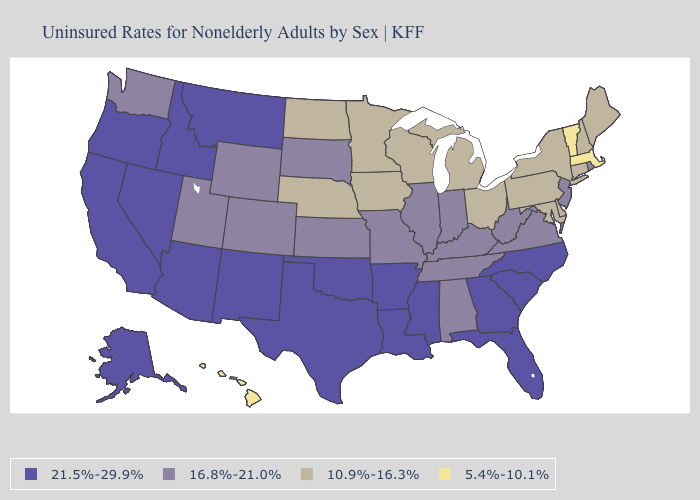What is the value of Nebraska?
Concise answer only. 10.9%-16.3%. Name the states that have a value in the range 10.9%-16.3%?
Quick response, please. Connecticut, Delaware, Iowa, Maine, Maryland, Michigan, Minnesota, Nebraska, New Hampshire, New York, North Dakota, Ohio, Pennsylvania, Wisconsin. Does the map have missing data?
Be succinct. No. Does Utah have a lower value than Georgia?
Quick response, please. Yes. Name the states that have a value in the range 16.8%-21.0%?
Be succinct. Alabama, Colorado, Illinois, Indiana, Kansas, Kentucky, Missouri, New Jersey, Rhode Island, South Dakota, Tennessee, Utah, Virginia, Washington, West Virginia, Wyoming. Name the states that have a value in the range 10.9%-16.3%?
Write a very short answer. Connecticut, Delaware, Iowa, Maine, Maryland, Michigan, Minnesota, Nebraska, New Hampshire, New York, North Dakota, Ohio, Pennsylvania, Wisconsin. What is the highest value in the MidWest ?
Short answer required. 16.8%-21.0%. Does Arkansas have the highest value in the USA?
Keep it brief. Yes. Does Alabama have the lowest value in the South?
Answer briefly. No. Does Maryland have a lower value than Wisconsin?
Answer briefly. No. What is the value of South Carolina?
Give a very brief answer. 21.5%-29.9%. What is the value of Massachusetts?
Give a very brief answer. 5.4%-10.1%. Which states have the highest value in the USA?
Write a very short answer. Alaska, Arizona, Arkansas, California, Florida, Georgia, Idaho, Louisiana, Mississippi, Montana, Nevada, New Mexico, North Carolina, Oklahoma, Oregon, South Carolina, Texas. Does the map have missing data?
Concise answer only. No. What is the lowest value in the West?
Keep it brief. 5.4%-10.1%. 